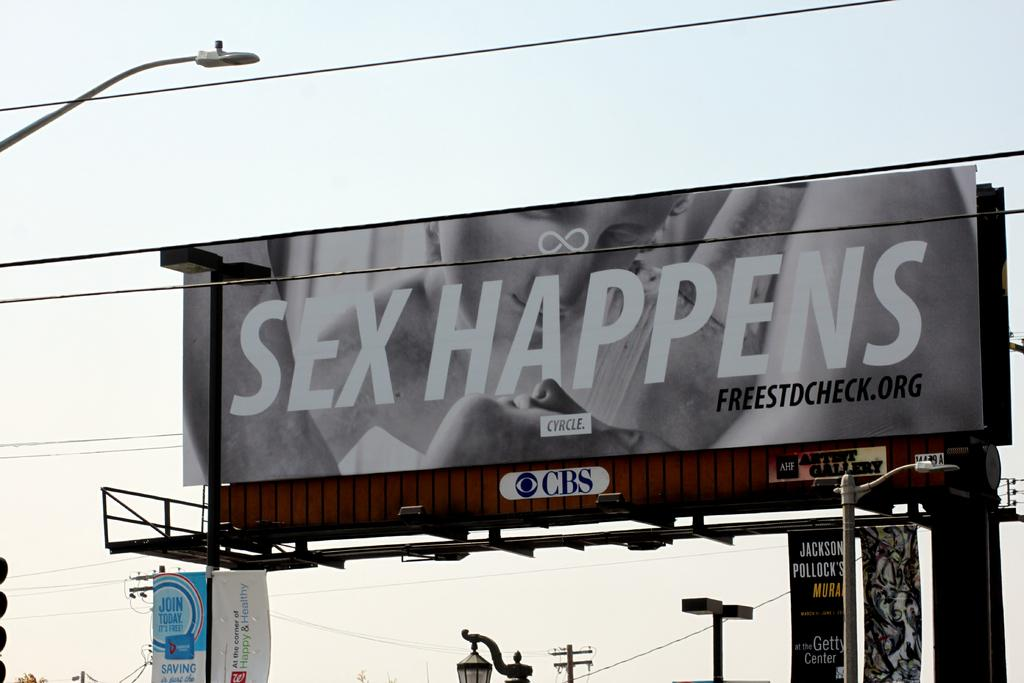<image>
Give a short and clear explanation of the subsequent image. A large billboard with the words Sex Happens on it. 